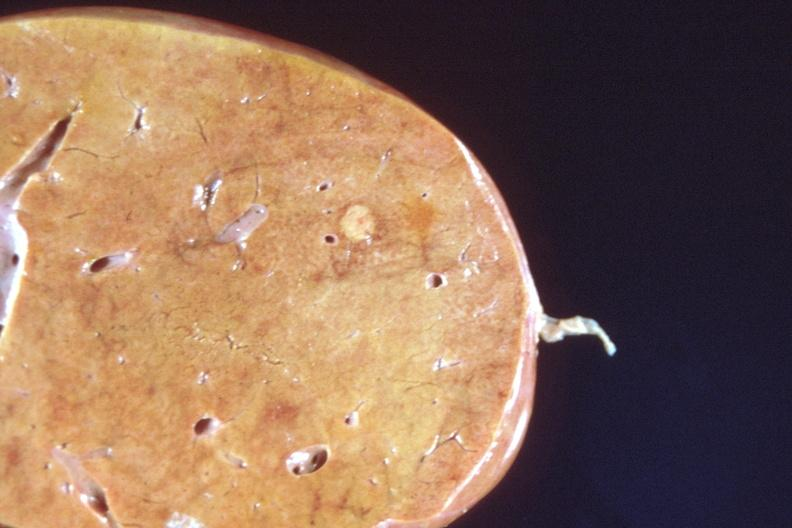s hepatobiliary present?
Answer the question using a single word or phrase. Yes 